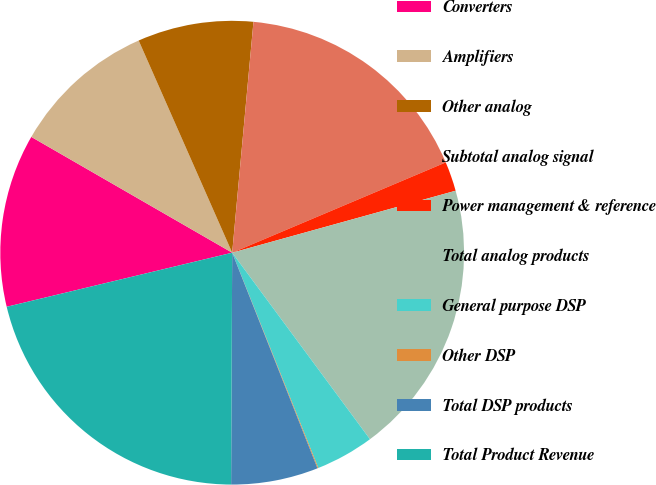<chart> <loc_0><loc_0><loc_500><loc_500><pie_chart><fcel>Converters<fcel>Amplifiers<fcel>Other analog<fcel>Subtotal analog signal<fcel>Power management & reference<fcel>Total analog products<fcel>General purpose DSP<fcel>Other DSP<fcel>Total DSP products<fcel>Total Product Revenue<nl><fcel>12.07%<fcel>10.07%<fcel>8.07%<fcel>17.17%<fcel>2.06%<fcel>19.18%<fcel>4.07%<fcel>0.06%<fcel>6.07%<fcel>21.18%<nl></chart> 